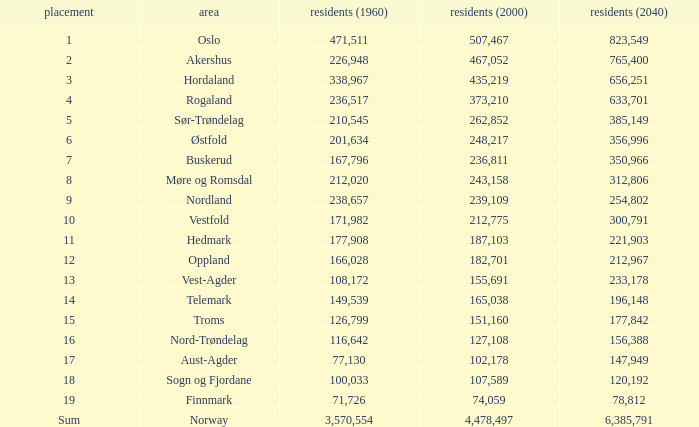What was Oslo's population in 1960, with a population of 507,467 in 2000? None. 